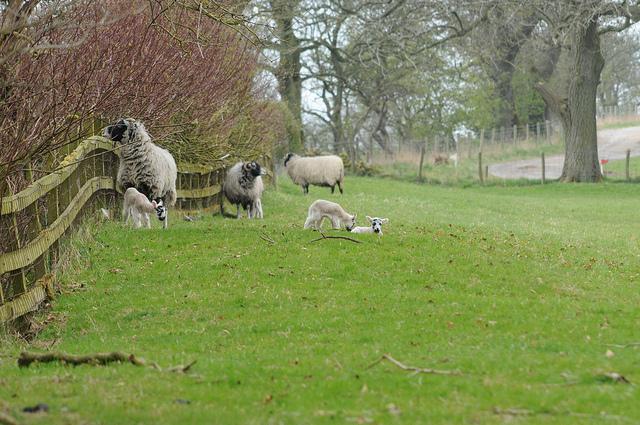Are all of these sheep full grown?
Concise answer only. No. What animals are in this picture?
Concise answer only. Sheep. Are there any branches on the ground?
Give a very brief answer. Yes. 